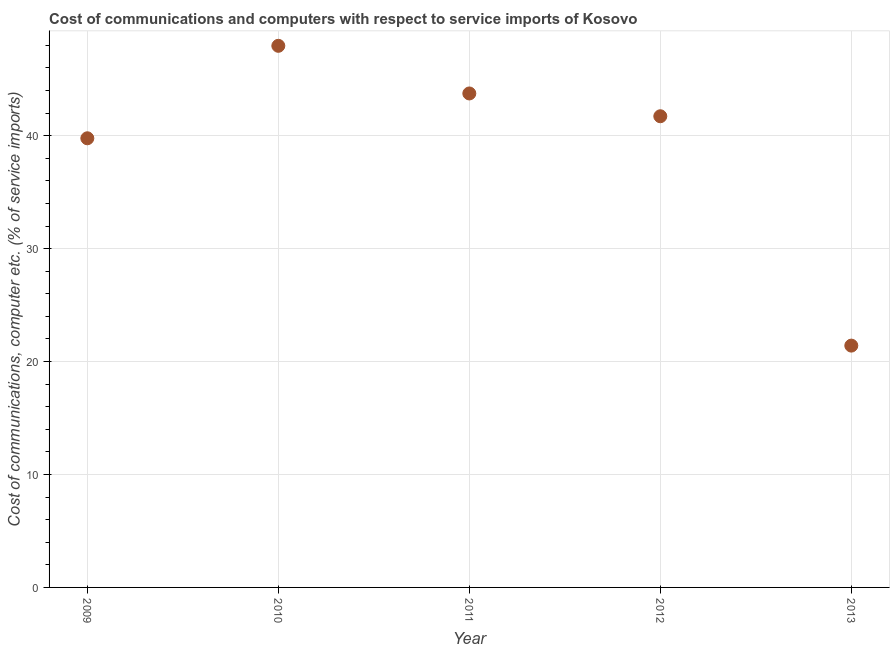What is the cost of communications and computer in 2010?
Provide a succinct answer. 47.96. Across all years, what is the maximum cost of communications and computer?
Your answer should be very brief. 47.96. Across all years, what is the minimum cost of communications and computer?
Give a very brief answer. 21.41. In which year was the cost of communications and computer maximum?
Keep it short and to the point. 2010. What is the sum of the cost of communications and computer?
Ensure brevity in your answer.  194.6. What is the difference between the cost of communications and computer in 2011 and 2013?
Your response must be concise. 22.33. What is the average cost of communications and computer per year?
Provide a succinct answer. 38.92. What is the median cost of communications and computer?
Provide a succinct answer. 41.72. In how many years, is the cost of communications and computer greater than 2 %?
Make the answer very short. 5. Do a majority of the years between 2009 and 2013 (inclusive) have cost of communications and computer greater than 42 %?
Provide a succinct answer. No. What is the ratio of the cost of communications and computer in 2009 to that in 2011?
Provide a short and direct response. 0.91. Is the cost of communications and computer in 2009 less than that in 2012?
Provide a succinct answer. Yes. What is the difference between the highest and the second highest cost of communications and computer?
Offer a terse response. 4.22. What is the difference between the highest and the lowest cost of communications and computer?
Give a very brief answer. 26.55. In how many years, is the cost of communications and computer greater than the average cost of communications and computer taken over all years?
Give a very brief answer. 4. How many dotlines are there?
Make the answer very short. 1. How many years are there in the graph?
Keep it short and to the point. 5. Are the values on the major ticks of Y-axis written in scientific E-notation?
Offer a terse response. No. What is the title of the graph?
Keep it short and to the point. Cost of communications and computers with respect to service imports of Kosovo. What is the label or title of the Y-axis?
Keep it short and to the point. Cost of communications, computer etc. (% of service imports). What is the Cost of communications, computer etc. (% of service imports) in 2009?
Provide a short and direct response. 39.77. What is the Cost of communications, computer etc. (% of service imports) in 2010?
Your answer should be very brief. 47.96. What is the Cost of communications, computer etc. (% of service imports) in 2011?
Offer a very short reply. 43.74. What is the Cost of communications, computer etc. (% of service imports) in 2012?
Ensure brevity in your answer.  41.72. What is the Cost of communications, computer etc. (% of service imports) in 2013?
Make the answer very short. 21.41. What is the difference between the Cost of communications, computer etc. (% of service imports) in 2009 and 2010?
Ensure brevity in your answer.  -8.19. What is the difference between the Cost of communications, computer etc. (% of service imports) in 2009 and 2011?
Your response must be concise. -3.97. What is the difference between the Cost of communications, computer etc. (% of service imports) in 2009 and 2012?
Give a very brief answer. -1.95. What is the difference between the Cost of communications, computer etc. (% of service imports) in 2009 and 2013?
Your answer should be compact. 18.36. What is the difference between the Cost of communications, computer etc. (% of service imports) in 2010 and 2011?
Offer a terse response. 4.22. What is the difference between the Cost of communications, computer etc. (% of service imports) in 2010 and 2012?
Keep it short and to the point. 6.24. What is the difference between the Cost of communications, computer etc. (% of service imports) in 2010 and 2013?
Offer a terse response. 26.55. What is the difference between the Cost of communications, computer etc. (% of service imports) in 2011 and 2012?
Give a very brief answer. 2.02. What is the difference between the Cost of communications, computer etc. (% of service imports) in 2011 and 2013?
Provide a short and direct response. 22.33. What is the difference between the Cost of communications, computer etc. (% of service imports) in 2012 and 2013?
Your answer should be very brief. 20.31. What is the ratio of the Cost of communications, computer etc. (% of service imports) in 2009 to that in 2010?
Ensure brevity in your answer.  0.83. What is the ratio of the Cost of communications, computer etc. (% of service imports) in 2009 to that in 2011?
Your response must be concise. 0.91. What is the ratio of the Cost of communications, computer etc. (% of service imports) in 2009 to that in 2012?
Provide a short and direct response. 0.95. What is the ratio of the Cost of communications, computer etc. (% of service imports) in 2009 to that in 2013?
Provide a short and direct response. 1.86. What is the ratio of the Cost of communications, computer etc. (% of service imports) in 2010 to that in 2011?
Make the answer very short. 1.1. What is the ratio of the Cost of communications, computer etc. (% of service imports) in 2010 to that in 2012?
Ensure brevity in your answer.  1.15. What is the ratio of the Cost of communications, computer etc. (% of service imports) in 2010 to that in 2013?
Keep it short and to the point. 2.24. What is the ratio of the Cost of communications, computer etc. (% of service imports) in 2011 to that in 2012?
Provide a succinct answer. 1.05. What is the ratio of the Cost of communications, computer etc. (% of service imports) in 2011 to that in 2013?
Your response must be concise. 2.04. What is the ratio of the Cost of communications, computer etc. (% of service imports) in 2012 to that in 2013?
Your response must be concise. 1.95. 